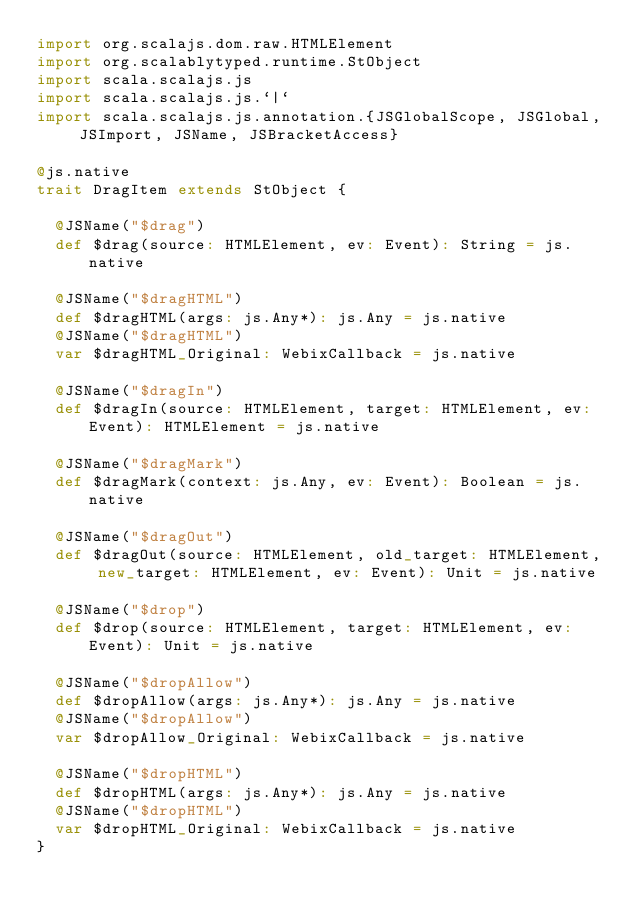Convert code to text. <code><loc_0><loc_0><loc_500><loc_500><_Scala_>import org.scalajs.dom.raw.HTMLElement
import org.scalablytyped.runtime.StObject
import scala.scalajs.js
import scala.scalajs.js.`|`
import scala.scalajs.js.annotation.{JSGlobalScope, JSGlobal, JSImport, JSName, JSBracketAccess}

@js.native
trait DragItem extends StObject {
  
  @JSName("$drag")
  def $drag(source: HTMLElement, ev: Event): String = js.native
  
  @JSName("$dragHTML")
  def $dragHTML(args: js.Any*): js.Any = js.native
  @JSName("$dragHTML")
  var $dragHTML_Original: WebixCallback = js.native
  
  @JSName("$dragIn")
  def $dragIn(source: HTMLElement, target: HTMLElement, ev: Event): HTMLElement = js.native
  
  @JSName("$dragMark")
  def $dragMark(context: js.Any, ev: Event): Boolean = js.native
  
  @JSName("$dragOut")
  def $dragOut(source: HTMLElement, old_target: HTMLElement, new_target: HTMLElement, ev: Event): Unit = js.native
  
  @JSName("$drop")
  def $drop(source: HTMLElement, target: HTMLElement, ev: Event): Unit = js.native
  
  @JSName("$dropAllow")
  def $dropAllow(args: js.Any*): js.Any = js.native
  @JSName("$dropAllow")
  var $dropAllow_Original: WebixCallback = js.native
  
  @JSName("$dropHTML")
  def $dropHTML(args: js.Any*): js.Any = js.native
  @JSName("$dropHTML")
  var $dropHTML_Original: WebixCallback = js.native
}
</code> 